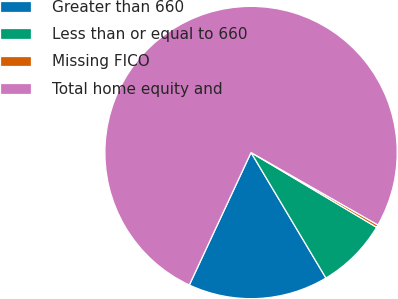<chart> <loc_0><loc_0><loc_500><loc_500><pie_chart><fcel>Greater than 660<fcel>Less than or equal to 660<fcel>Missing FICO<fcel>Total home equity and<nl><fcel>15.5%<fcel>7.89%<fcel>0.29%<fcel>76.32%<nl></chart> 